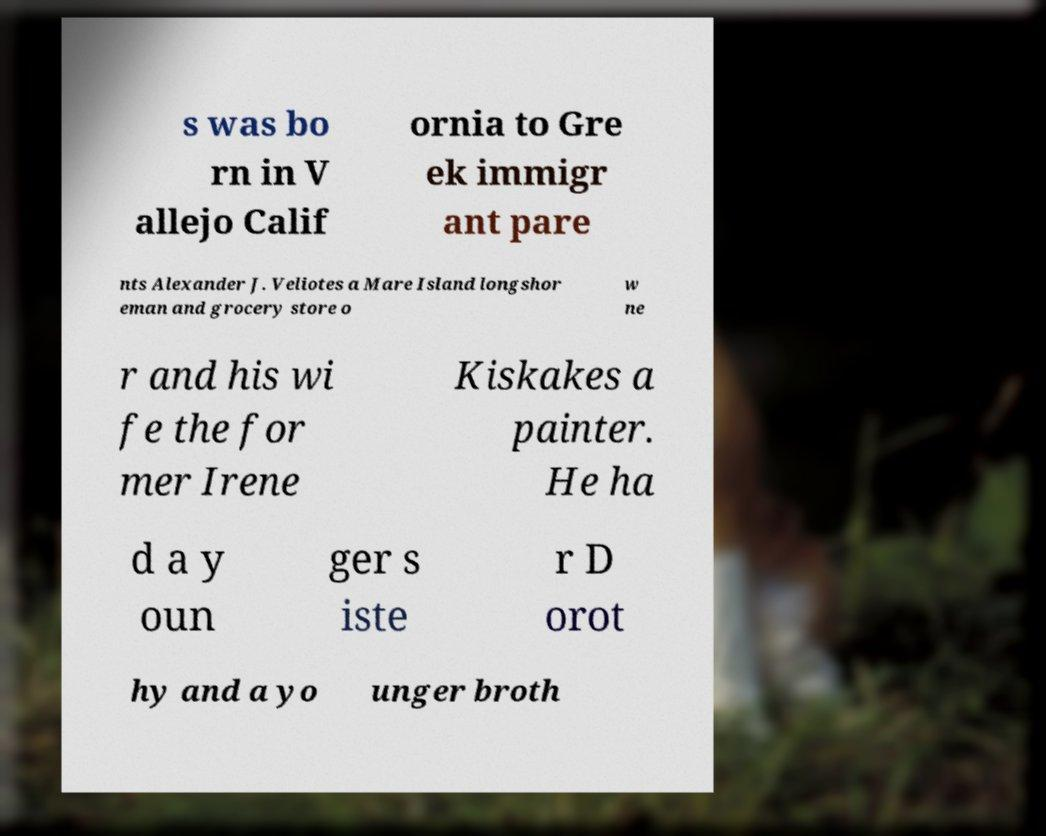Could you assist in decoding the text presented in this image and type it out clearly? s was bo rn in V allejo Calif ornia to Gre ek immigr ant pare nts Alexander J. Veliotes a Mare Island longshor eman and grocery store o w ne r and his wi fe the for mer Irene Kiskakes a painter. He ha d a y oun ger s iste r D orot hy and a yo unger broth 